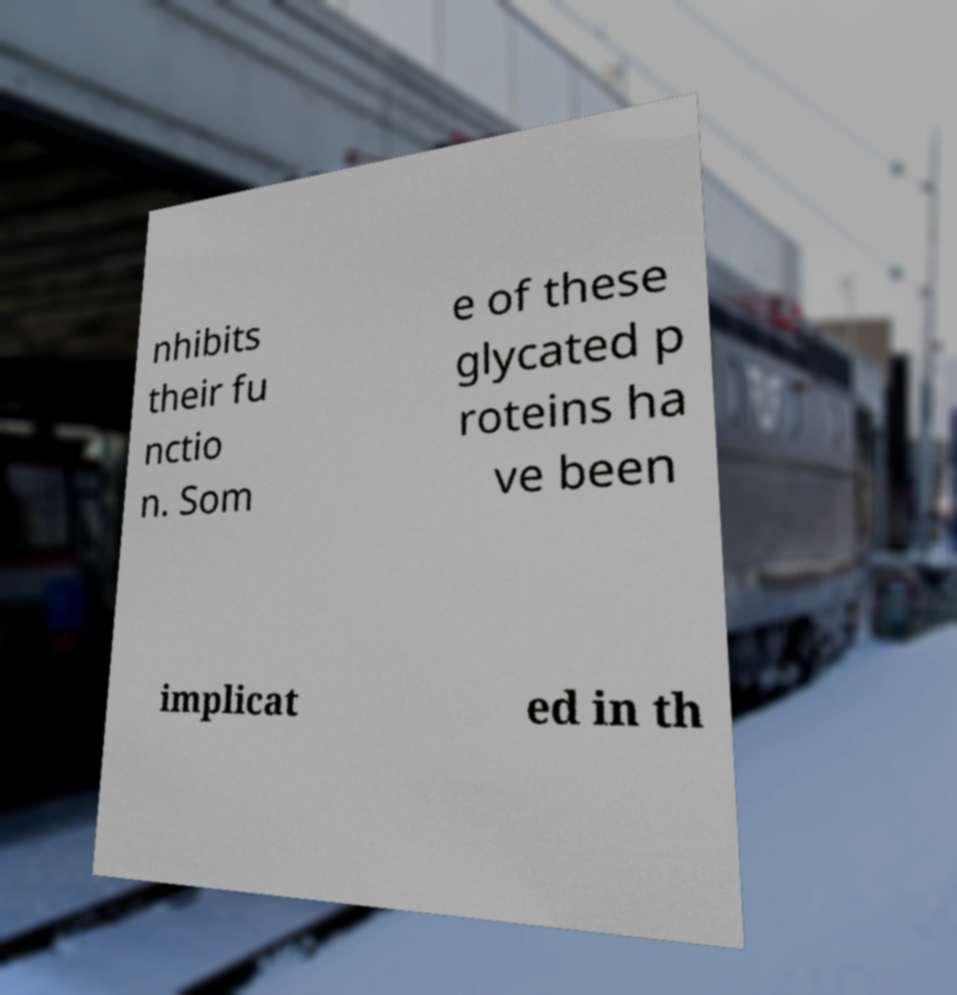What messages or text are displayed in this image? I need them in a readable, typed format. nhibits their fu nctio n. Som e of these glycated p roteins ha ve been implicat ed in th 